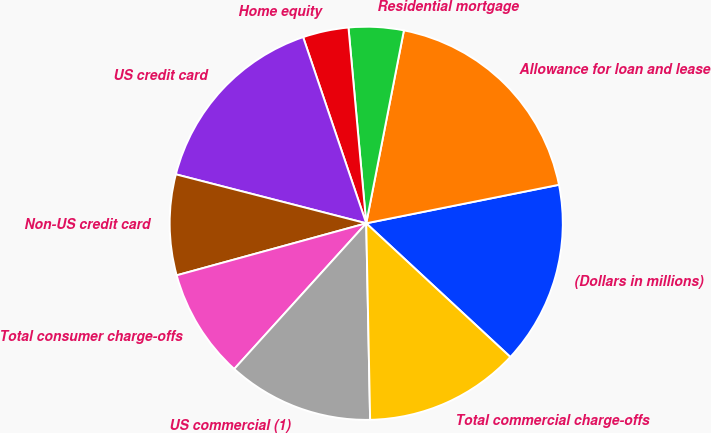<chart> <loc_0><loc_0><loc_500><loc_500><pie_chart><fcel>(Dollars in millions)<fcel>Allowance for loan and lease<fcel>Residential mortgage<fcel>Home equity<fcel>US credit card<fcel>Non-US credit card<fcel>Total consumer charge-offs<fcel>US commercial (1)<fcel>Total commercial charge-offs<nl><fcel>15.04%<fcel>18.79%<fcel>4.51%<fcel>3.76%<fcel>15.79%<fcel>8.27%<fcel>9.02%<fcel>12.03%<fcel>12.78%<nl></chart> 